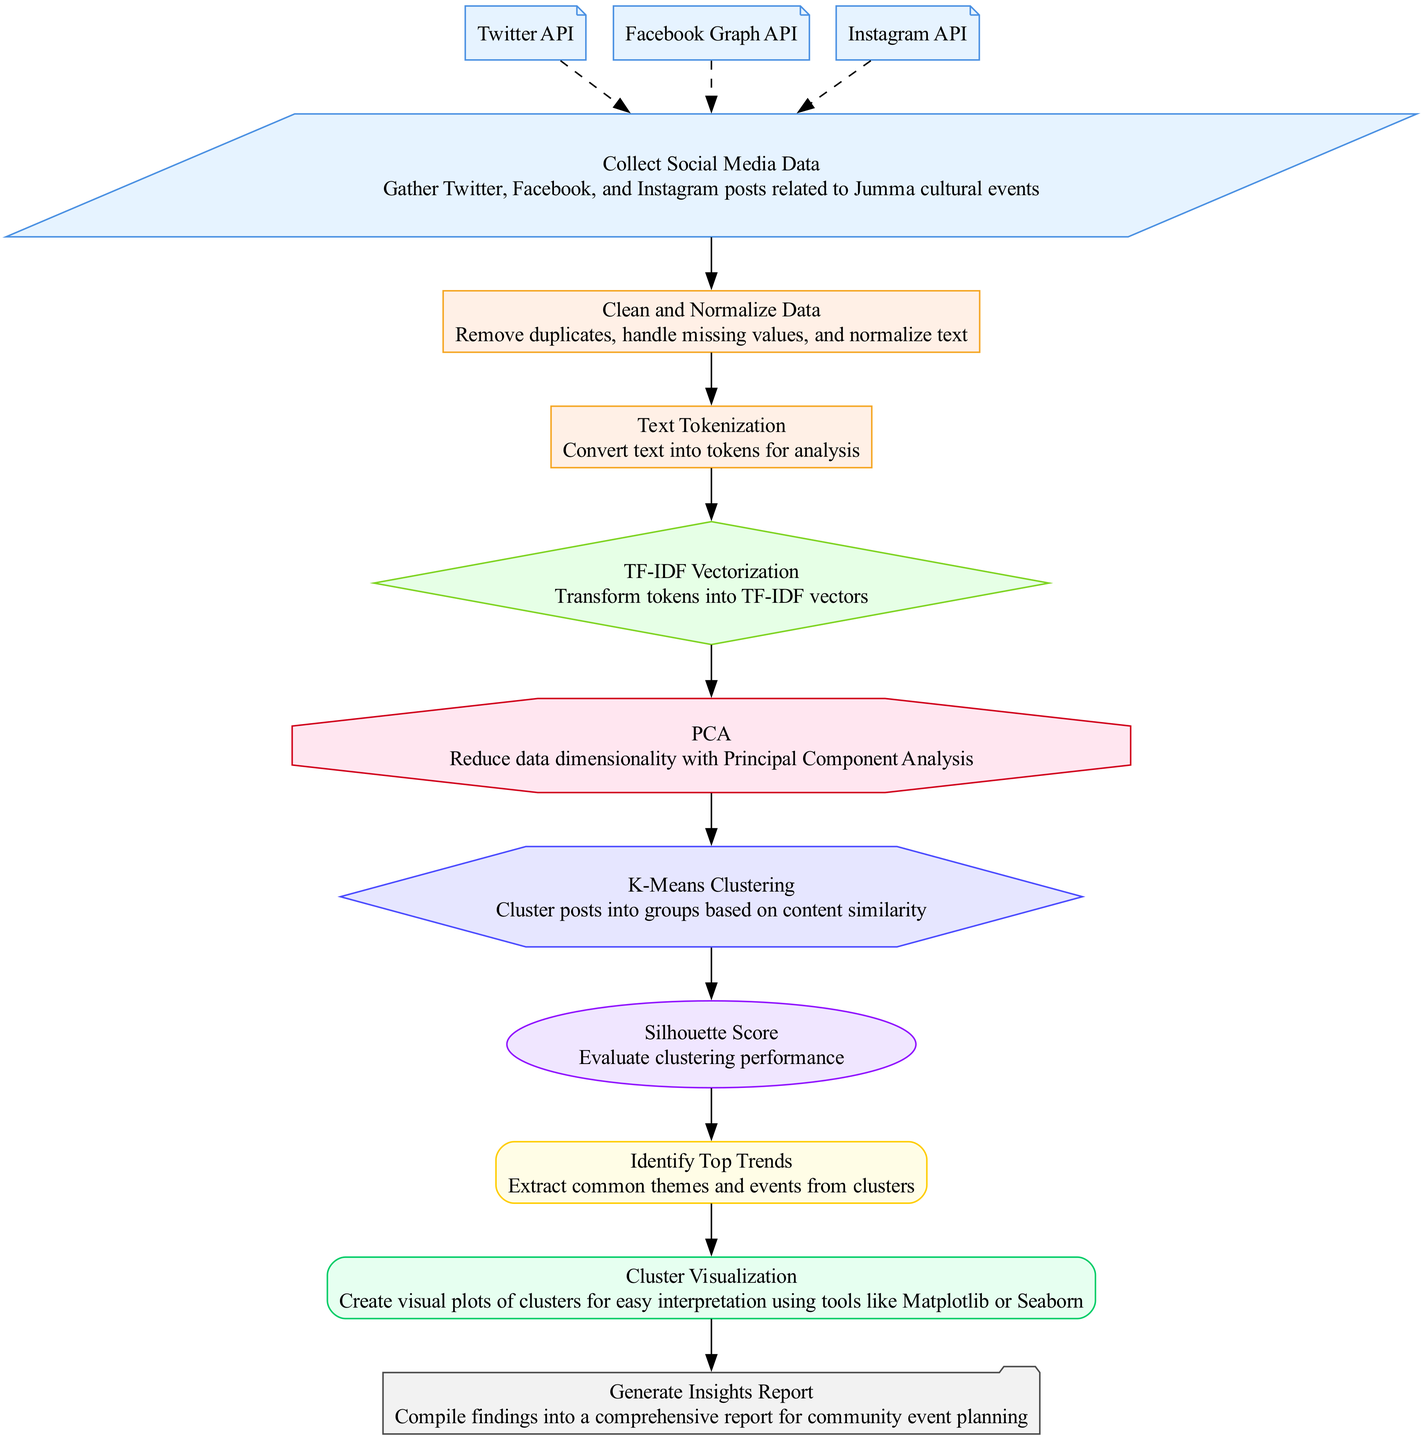What is the first step in the diagram? The first step is "Collect Social Media Data," where data is gathered from various sources.
Answer: Collect Social Media Data How many data sources are listed in the "Collect Social Media Data" node? There are three data sources mentioned: Twitter API, Facebook Graph API, and Instagram API.
Answer: Three Which algorithm is used for clustering in this diagram? The algorithm used for clustering is K-Means Clustering, which groups similar posts.
Answer: K-Means Clustering What type of method is employed to evaluate clustering performance? The method used for evaluation is the Silhouette Score, which assesses how well clusters are defined.
Answer: Silhouette Score Which step follows "Text Tokenization"? The step that follows "Text Tokenization" is "TF-IDF Vectorization," where tokens are transformed into vectors for analysis.
Answer: TF-IDF Vectorization What shape represents the "Dimensionality Reduction" node? The shape representing the "Dimensionality Reduction" node is an octagon, indicating a distinct processing role.
Answer: Octagon How does the diagram visualize clusters for interpretation? The diagram visualizes clusters using a visualization step called "Cluster Visualization," which creates plots for easier understanding.
Answer: Cluster Visualization What is the final output of this machine learning pipeline? The final output of the pipeline is a "Generate Insights Report," which compiles findings for community event planning.
Answer: Generate Insights Report How many main processing steps are involved in this diagram? The diagram includes seven main processing steps, from data collection to report generation.
Answer: Seven 